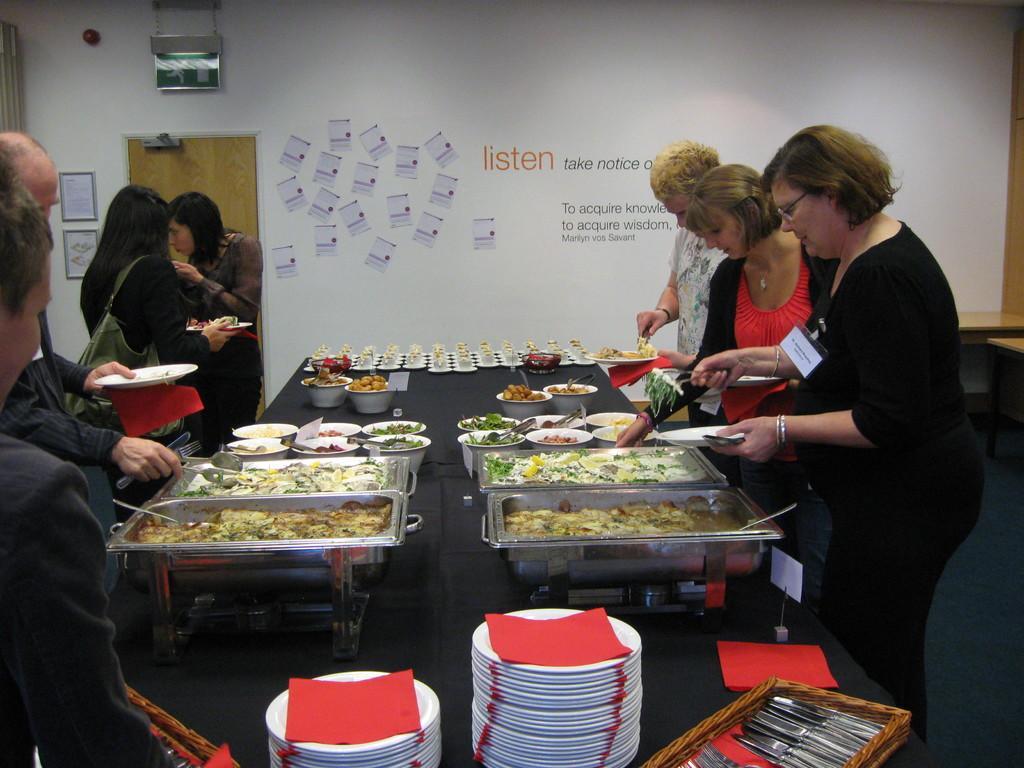How would you summarize this image in a sentence or two? At the bottom of the image there is a table. On the table there are trays and bowls with food items. And also on the table there are plates, tissues, basket with knives and many other items. In the image there are few people standing and holding plates and some other items in their hands. Behind them there is a wall with frames, door, papers and something is written on the wall. Above the door on the wall there is a sign board. On the right side of the image there are tables. 